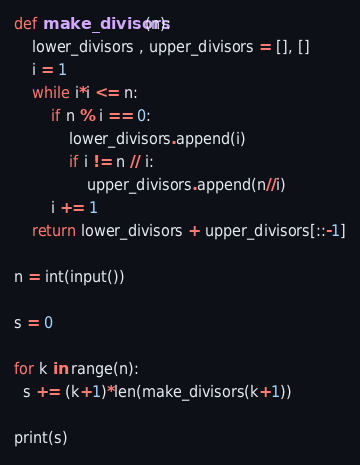<code> <loc_0><loc_0><loc_500><loc_500><_Python_>def make_divisors(n):
    lower_divisors , upper_divisors = [], []
    i = 1
    while i*i <= n:
        if n % i == 0:
            lower_divisors.append(i)
            if i != n // i:
                upper_divisors.append(n//i)
        i += 1
    return lower_divisors + upper_divisors[::-1]

n = int(input())

s = 0

for k in range(n):
  s += (k+1)*len(make_divisors(k+1))
  
print(s)</code> 